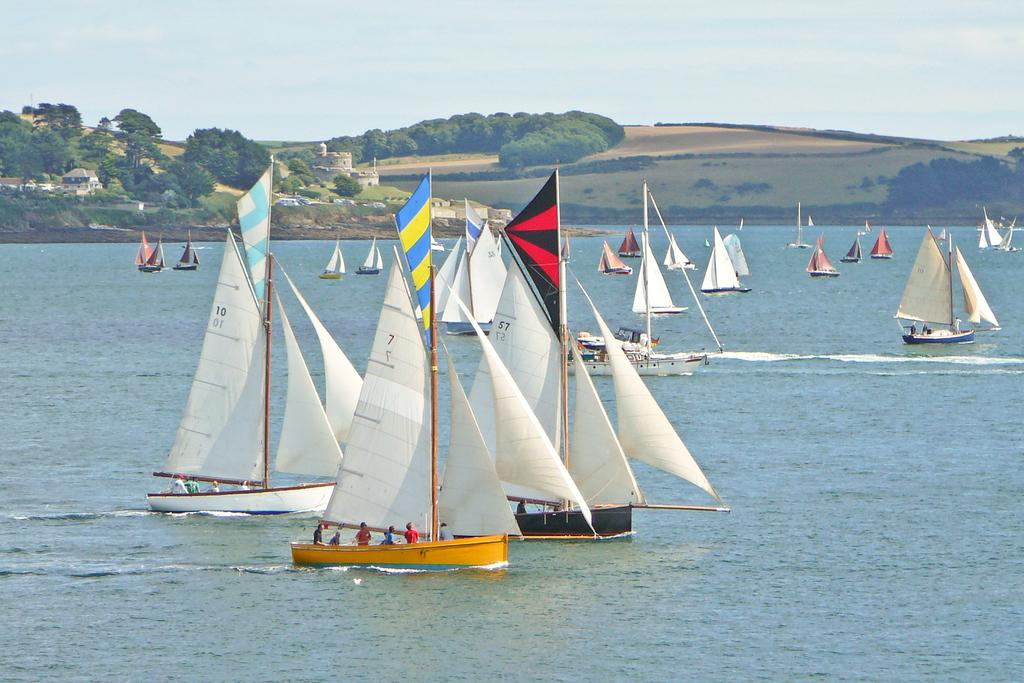What type of vehicles are in the water in the image? There are boats in the water in the image. What are the people in the boats doing? People are traveling in the boats. What can be seen around the boats in the image? There are trees and houses visible around the boats. What type of government is depicted in the image? There is no depiction of a government in the image; it features boats in the water with people traveling in them and trees and houses around them. 